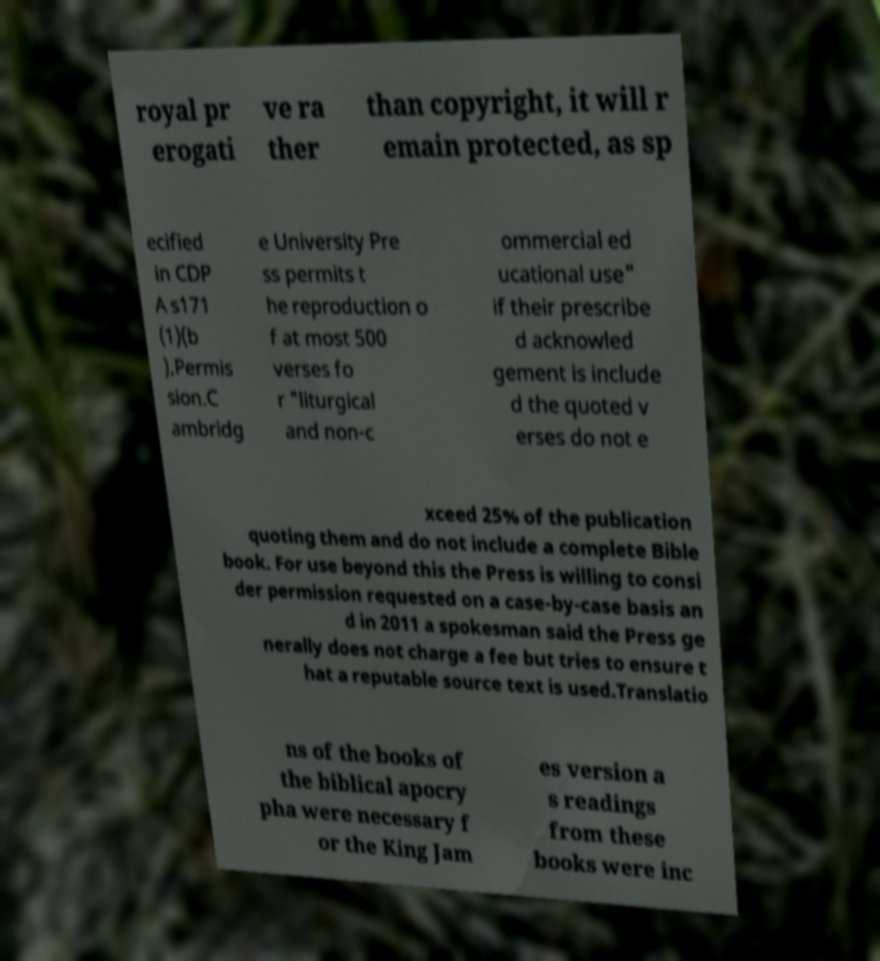What messages or text are displayed in this image? I need them in a readable, typed format. royal pr erogati ve ra ther than copyright, it will r emain protected, as sp ecified in CDP A s171 (1)(b ).Permis sion.C ambridg e University Pre ss permits t he reproduction o f at most 500 verses fo r "liturgical and non-c ommercial ed ucational use" if their prescribe d acknowled gement is include d the quoted v erses do not e xceed 25% of the publication quoting them and do not include a complete Bible book. For use beyond this the Press is willing to consi der permission requested on a case-by-case basis an d in 2011 a spokesman said the Press ge nerally does not charge a fee but tries to ensure t hat a reputable source text is used.Translatio ns of the books of the biblical apocry pha were necessary f or the King Jam es version a s readings from these books were inc 